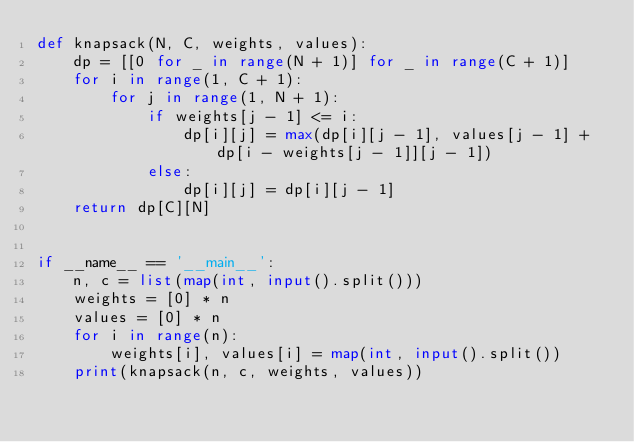<code> <loc_0><loc_0><loc_500><loc_500><_Python_>def knapsack(N, C, weights, values):
    dp = [[0 for _ in range(N + 1)] for _ in range(C + 1)]
    for i in range(1, C + 1):
        for j in range(1, N + 1):
            if weights[j - 1] <= i:
                dp[i][j] = max(dp[i][j - 1], values[j - 1] + dp[i - weights[j - 1]][j - 1])
            else:
                dp[i][j] = dp[i][j - 1]
    return dp[C][N]


if __name__ == '__main__':
    n, c = list(map(int, input().split()))
    weights = [0] * n
    values = [0] * n
    for i in range(n):
        weights[i], values[i] = map(int, input().split())
    print(knapsack(n, c, weights, values))
</code> 